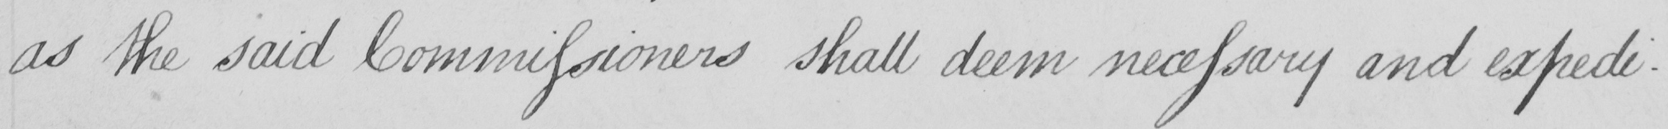Can you tell me what this handwritten text says? as the said Commissioners shall deem necessary and expedi- 